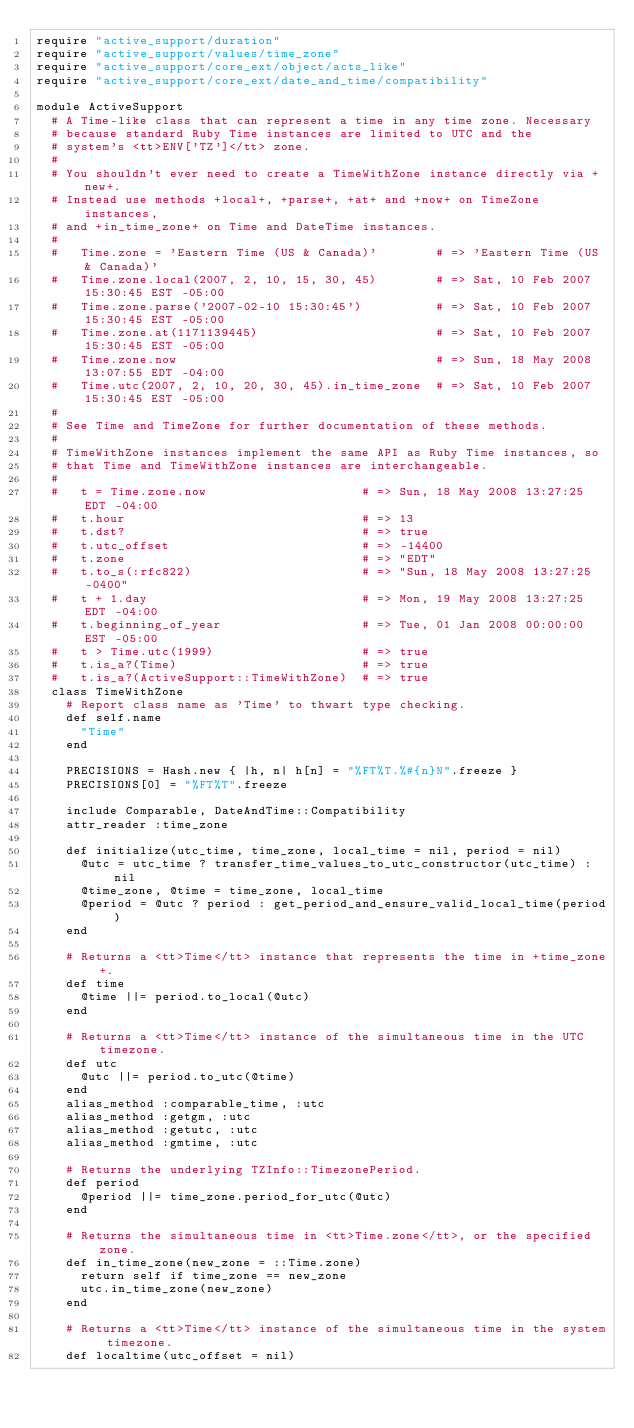<code> <loc_0><loc_0><loc_500><loc_500><_Ruby_>require "active_support/duration"
require "active_support/values/time_zone"
require "active_support/core_ext/object/acts_like"
require "active_support/core_ext/date_and_time/compatibility"

module ActiveSupport
  # A Time-like class that can represent a time in any time zone. Necessary
  # because standard Ruby Time instances are limited to UTC and the
  # system's <tt>ENV['TZ']</tt> zone.
  #
  # You shouldn't ever need to create a TimeWithZone instance directly via +new+.
  # Instead use methods +local+, +parse+, +at+ and +now+ on TimeZone instances,
  # and +in_time_zone+ on Time and DateTime instances.
  #
  #   Time.zone = 'Eastern Time (US & Canada)'        # => 'Eastern Time (US & Canada)'
  #   Time.zone.local(2007, 2, 10, 15, 30, 45)        # => Sat, 10 Feb 2007 15:30:45 EST -05:00
  #   Time.zone.parse('2007-02-10 15:30:45')          # => Sat, 10 Feb 2007 15:30:45 EST -05:00
  #   Time.zone.at(1171139445)                        # => Sat, 10 Feb 2007 15:30:45 EST -05:00
  #   Time.zone.now                                   # => Sun, 18 May 2008 13:07:55 EDT -04:00
  #   Time.utc(2007, 2, 10, 20, 30, 45).in_time_zone  # => Sat, 10 Feb 2007 15:30:45 EST -05:00
  #
  # See Time and TimeZone for further documentation of these methods.
  #
  # TimeWithZone instances implement the same API as Ruby Time instances, so
  # that Time and TimeWithZone instances are interchangeable.
  #
  #   t = Time.zone.now                     # => Sun, 18 May 2008 13:27:25 EDT -04:00
  #   t.hour                                # => 13
  #   t.dst?                                # => true
  #   t.utc_offset                          # => -14400
  #   t.zone                                # => "EDT"
  #   t.to_s(:rfc822)                       # => "Sun, 18 May 2008 13:27:25 -0400"
  #   t + 1.day                             # => Mon, 19 May 2008 13:27:25 EDT -04:00
  #   t.beginning_of_year                   # => Tue, 01 Jan 2008 00:00:00 EST -05:00
  #   t > Time.utc(1999)                    # => true
  #   t.is_a?(Time)                         # => true
  #   t.is_a?(ActiveSupport::TimeWithZone)  # => true
  class TimeWithZone
    # Report class name as 'Time' to thwart type checking.
    def self.name
      "Time"
    end

    PRECISIONS = Hash.new { |h, n| h[n] = "%FT%T.%#{n}N".freeze }
    PRECISIONS[0] = "%FT%T".freeze

    include Comparable, DateAndTime::Compatibility
    attr_reader :time_zone

    def initialize(utc_time, time_zone, local_time = nil, period = nil)
      @utc = utc_time ? transfer_time_values_to_utc_constructor(utc_time) : nil
      @time_zone, @time = time_zone, local_time
      @period = @utc ? period : get_period_and_ensure_valid_local_time(period)
    end

    # Returns a <tt>Time</tt> instance that represents the time in +time_zone+.
    def time
      @time ||= period.to_local(@utc)
    end

    # Returns a <tt>Time</tt> instance of the simultaneous time in the UTC timezone.
    def utc
      @utc ||= period.to_utc(@time)
    end
    alias_method :comparable_time, :utc
    alias_method :getgm, :utc
    alias_method :getutc, :utc
    alias_method :gmtime, :utc

    # Returns the underlying TZInfo::TimezonePeriod.
    def period
      @period ||= time_zone.period_for_utc(@utc)
    end

    # Returns the simultaneous time in <tt>Time.zone</tt>, or the specified zone.
    def in_time_zone(new_zone = ::Time.zone)
      return self if time_zone == new_zone
      utc.in_time_zone(new_zone)
    end

    # Returns a <tt>Time</tt> instance of the simultaneous time in the system timezone.
    def localtime(utc_offset = nil)</code> 